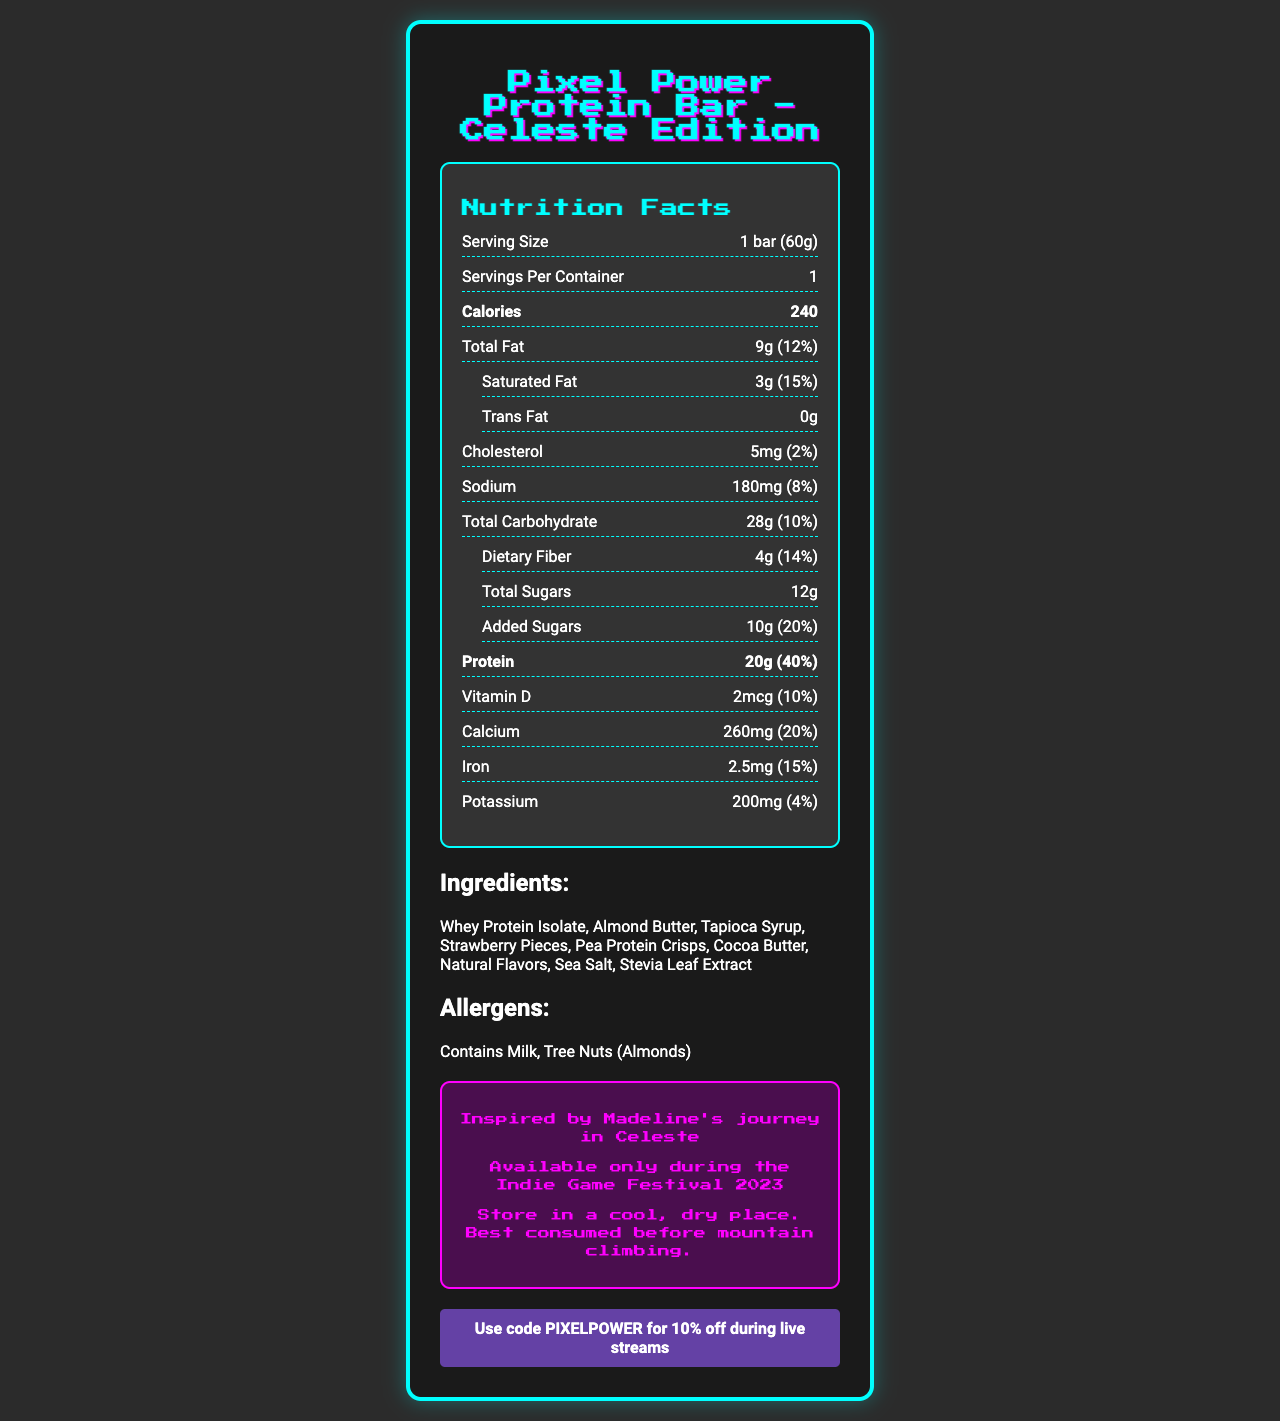what is the serving size of the Pixel Power Protein Bar? The serving size is explicitly mentioned as "1 bar (60g)" on the document.
Answer: 1 bar (60g) how many calories are in one serving? The document clearly states the number of calories as 240.
Answer: 240 calories what is the total amount of protein per serving? The total amount of protein per serving is listed as 20g.
Answer: 20g what is the percentage of daily value for calcium? The document shows that the daily value percentage for calcium is 20%.
Answer: 20% Name two main allergens in the Pixel Power Protein Bar. The allergen information indicates that the bar contains Milk and Tree Nuts (Almonds).
Answer: Milk, Tree Nuts (Almonds) what is the amount of dietary fiber in one bar? The amount of dietary fiber per serving is noted as 4g on the document.
Answer: 4g does the product contain trans fat? The document mentions that the product contains 0g of trans fat.
Answer: No what are the first two ingredients listed for the Pixel Power Protein Bar? A. Whey Protein Isolate and Pea Protein Crisps B. Whey Protein Isolate and Almond Butter C. Cocoa Butter and Natural Flavors The first two ingredients listed are Whey Protein Isolate and Almond Butter.
Answer: B. Whey Protein Isolate and Almond Butter how much vitamin D is in one serving? A. 1mcg B. 2mcg C. 10mcg D. 20mcg The nutrition facts state that there are 2mcg of vitamin D per serving.
Answer: B. 2mcg how much added sugar is there in the protein bar? The document reports that there are 10g of added sugars.
Answer: 10g is the bar available year-round? The document notes that the bar is a limited edition, available only during the Indie Game Festival 2023.
Answer: No summarize the document. The document primarily provides nutritional details, ingredients, allergens, and special promotional information about the Pixel Power Protein Bar, emphasizing its limited availability during a festival.
Answer: The Pixel Power Protein Bar - Celeste Edition is a limited-edition protein bar inspired by the indie game Celeste. It contains 240 calories per 60g serving and includes notable nutrients such as 20g of protein, 9g of fat, 28g of carbohydrates, with key vitamins and minerals. The bar's primary ingredients are Whey Protein Isolate and Almond Butter, and it contains allergens like milk and tree nuts. This product is especially promoted with a Twitch discount code and is recommended to be stored in a cool, dry place. 